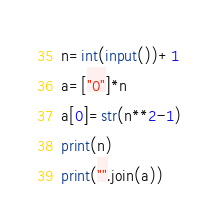Convert code to text. <code><loc_0><loc_0><loc_500><loc_500><_Python_>n=int(input())+1
a=["0"]*n
a[0]=str(n**2-1)
print(n)
print("".join(a))</code> 